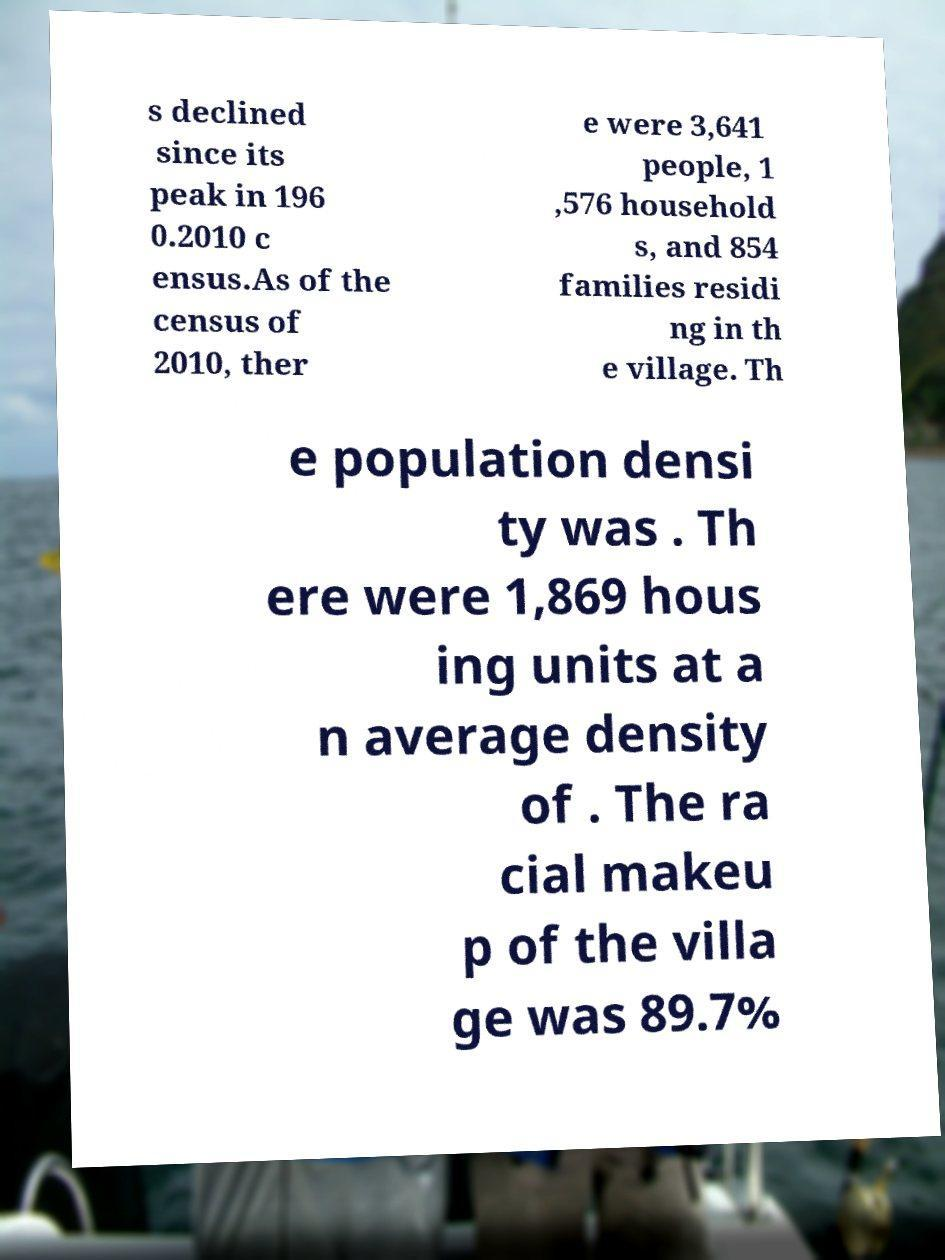Could you assist in decoding the text presented in this image and type it out clearly? s declined since its peak in 196 0.2010 c ensus.As of the census of 2010, ther e were 3,641 people, 1 ,576 household s, and 854 families residi ng in th e village. Th e population densi ty was . Th ere were 1,869 hous ing units at a n average density of . The ra cial makeu p of the villa ge was 89.7% 